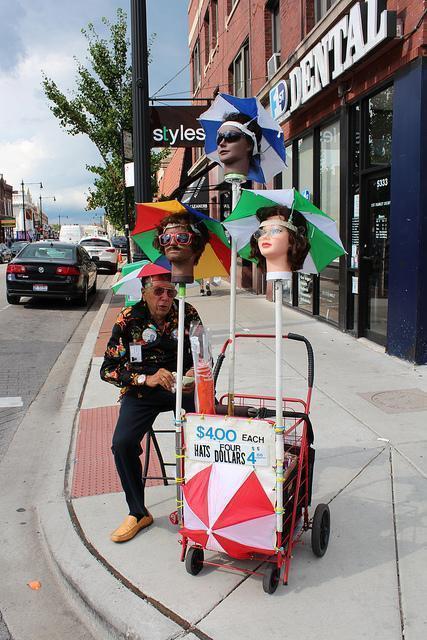What can the clinic on the right help you with?
Answer the question by selecting the correct answer among the 4 following choices.
Options: Eyes, feet, teeth, back. Teeth. 